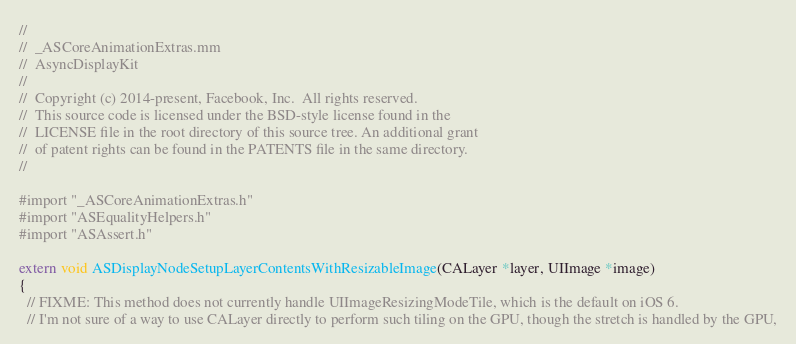<code> <loc_0><loc_0><loc_500><loc_500><_ObjectiveC_>//
//  _ASCoreAnimationExtras.mm
//  AsyncDisplayKit
//
//  Copyright (c) 2014-present, Facebook, Inc.  All rights reserved.
//  This source code is licensed under the BSD-style license found in the
//  LICENSE file in the root directory of this source tree. An additional grant
//  of patent rights can be found in the PATENTS file in the same directory.
//

#import "_ASCoreAnimationExtras.h"
#import "ASEqualityHelpers.h"
#import "ASAssert.h"

extern void ASDisplayNodeSetupLayerContentsWithResizableImage(CALayer *layer, UIImage *image)
{
  // FIXME: This method does not currently handle UIImageResizingModeTile, which is the default on iOS 6.
  // I'm not sure of a way to use CALayer directly to perform such tiling on the GPU, though the stretch is handled by the GPU,</code> 